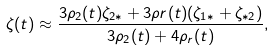<formula> <loc_0><loc_0><loc_500><loc_500>\zeta ( t ) \approx \frac { 3 \rho _ { 2 } ( t ) \zeta _ { 2 * } + 3 \rho r ( t ) ( \zeta _ { 1 * } + \zeta _ { * 2 } ) } { 3 \rho _ { 2 } ( t ) + 4 \rho _ { r } ( t ) } ,</formula> 